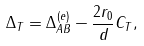Convert formula to latex. <formula><loc_0><loc_0><loc_500><loc_500>\Delta _ { T } = \Delta _ { A B } ^ { ( e ) } - \frac { 2 r _ { 0 } } { d } C _ { T } ,</formula> 